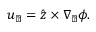<formula> <loc_0><loc_0><loc_500><loc_500>u _ { \perp } = \hat { z } \times \nabla _ { \perp } \phi .</formula> 